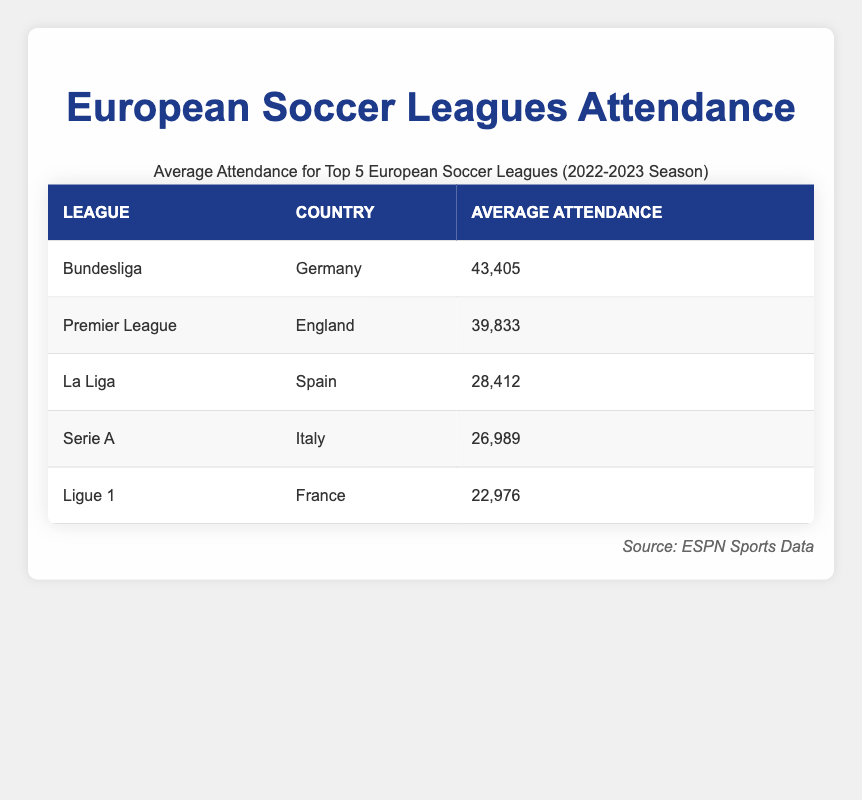What is the average attendance in Bundesliga? The table states that the average attendance in the Bundesliga is 43,405.
Answer: 43,405 Which league has a higher average attendance, Serie A or La Liga? The average attendance for Serie A is 26,989, while La Liga has 28,412. Since 28,412 is greater than 26,989, La Liga has a higher average attendance.
Answer: La Liga Is the average attendance in Premier League less than 40,000? The average attendance for the Premier League is 39,833, which is less than 40,000.
Answer: Yes What is the total average attendance of the top 5 leagues? To find the total average attendance, sum the averages: 43,405 + 39,833 + 28,412 + 26,989 + 22,976 = 161,615.
Answer: 161,615 How many leagues have an average attendance above 30,000? Only Bundesliga (43,405) and Premier League (39,833) have average attendance above 30,000, according to the table.
Answer: 2 Which league has the lowest average attendance? The table shows that Ligue 1 has the lowest average attendance at 22,976.
Answer: Ligue 1 What is the difference in average attendance between Ligue 1 and Serie A? The average attendance for Serie A is 26,989 and for Ligue 1 it's 22,976. The difference is 26,989 - 22,976 = 4,013.
Answer: 4,013 Does any league have an average attendance greater than 45,000? The maximum average attendance in the table is 43,405 for Bundesliga, which is not greater than 45,000.
Answer: No 